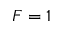Convert formula to latex. <formula><loc_0><loc_0><loc_500><loc_500>F = 1</formula> 